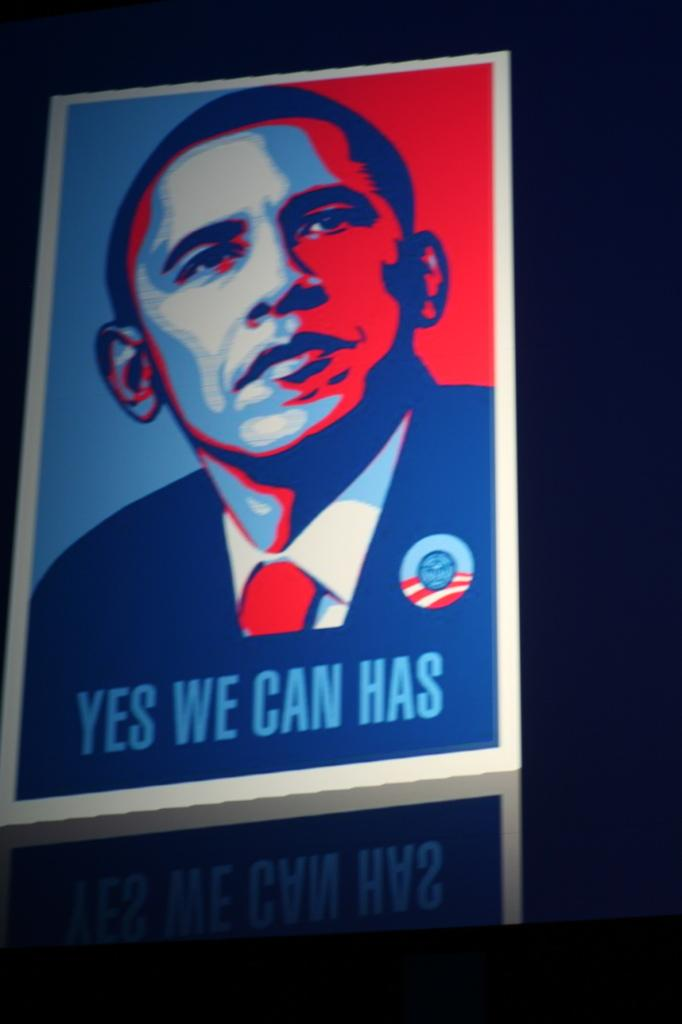<image>
Present a compact description of the photo's key features. a colorful poster reading Yes We Can Has 